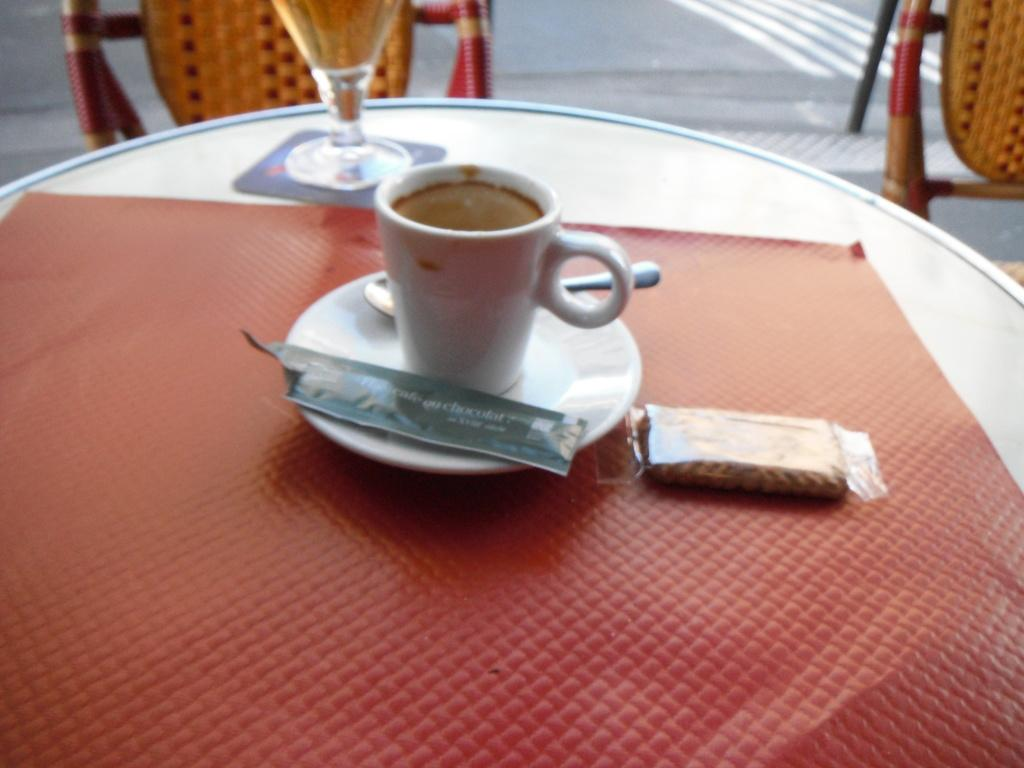What type of furniture is present in the image? There are chairs and a table in the image. What items can be seen on the table? There is a cup, a spoon, a plate, and a packet on the table. Can you describe the arrangement of the items on the table? The cup, spoon, plate, and packet are all placed on the table. What type of scissors can be seen cutting the growth on the table? There are no scissors or growth present on the table in the image. 